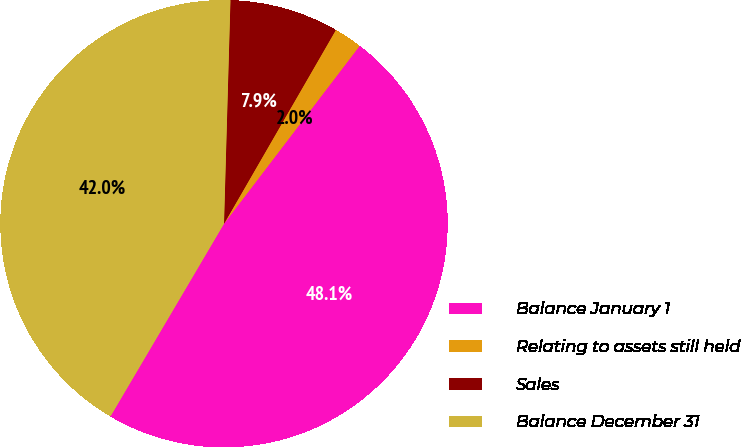<chart> <loc_0><loc_0><loc_500><loc_500><pie_chart><fcel>Balance January 1<fcel>Relating to assets still held<fcel>Sales<fcel>Balance December 31<nl><fcel>48.1%<fcel>2.04%<fcel>7.87%<fcel>41.98%<nl></chart> 